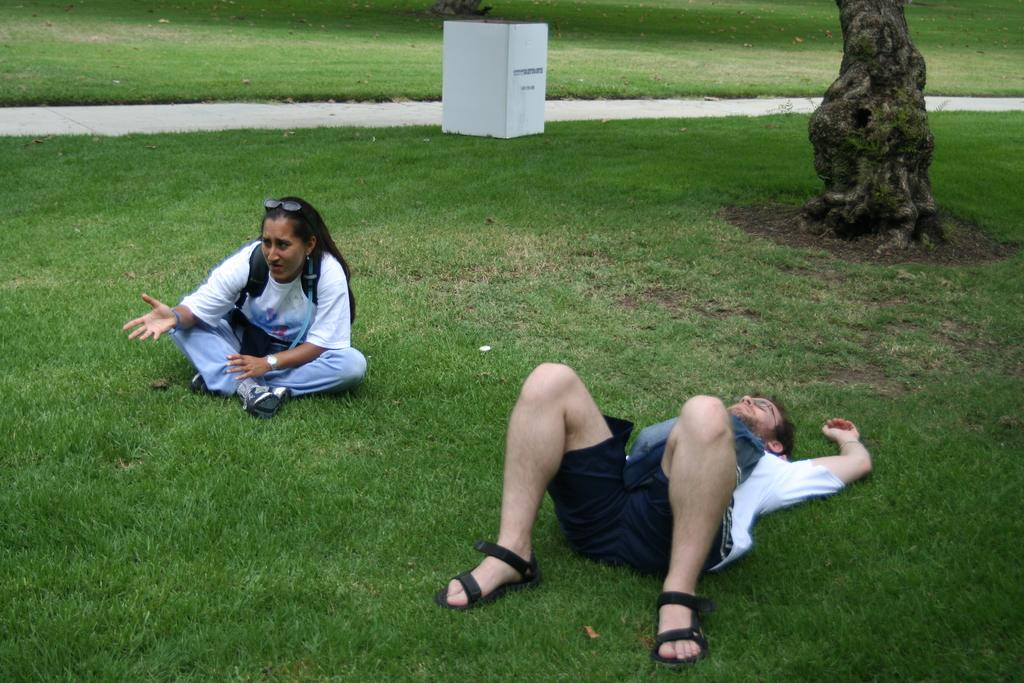What is the position of the man in the image? There is a man lying on the ground in the image. Who is with the man in the image? There is a woman sitting beside the man in the image. What type of accessory is present in the image? Goggles are present in the image. What time-telling device is visible in the image? A watch is visible in the image. What natural element is present in the image? There is a tree trunk in the image. What man-made object is present in the image? There is a box in the image. What type of surface is visible in the image? A path is visible in the image. What type of vegetation is present in the background of the image? The background of the image includes grass. What type of animal is the zebra in the image? There is no zebra present in the image. What type of medical professional is the doctor in the image? There is no doctor present in the image. 